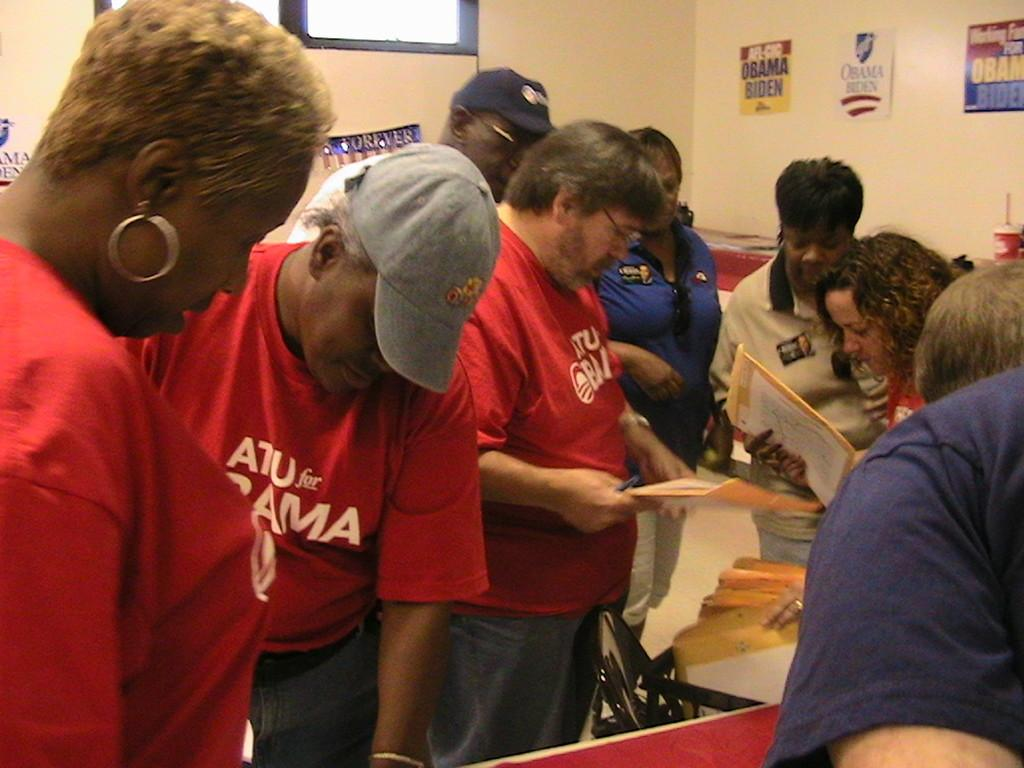What is the main subject of the image? The main subject of the image is a group of men. What are the men wearing in the image? The men are wearing red t-shirts in the image. What are the men holding in the image? The men are standing in front and holding an envelope in the image. What can be seen in the background of the image? There is a yellow wall in the background of the image. What type of wood can be seen in the image? There is no wood present in the image; it features a group of men wearing red t-shirts, holding an envelope, and standing in front of a yellow wall. 